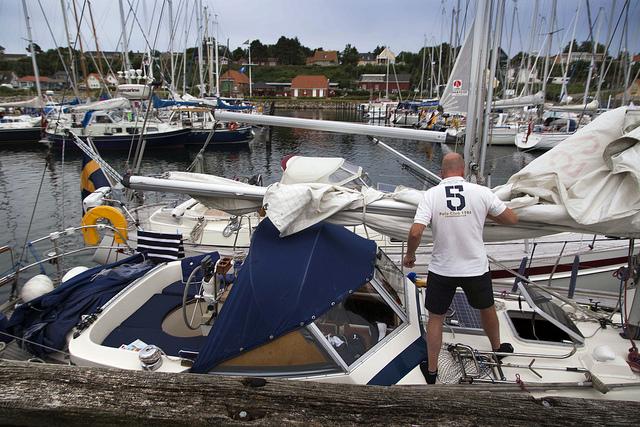What color is the man's shirt?
Write a very short answer. White. What is the number on the man's shirt?
Answer briefly. 5. Would you want to have a life jacket if you were on this form of transportation?
Write a very short answer. Yes. 